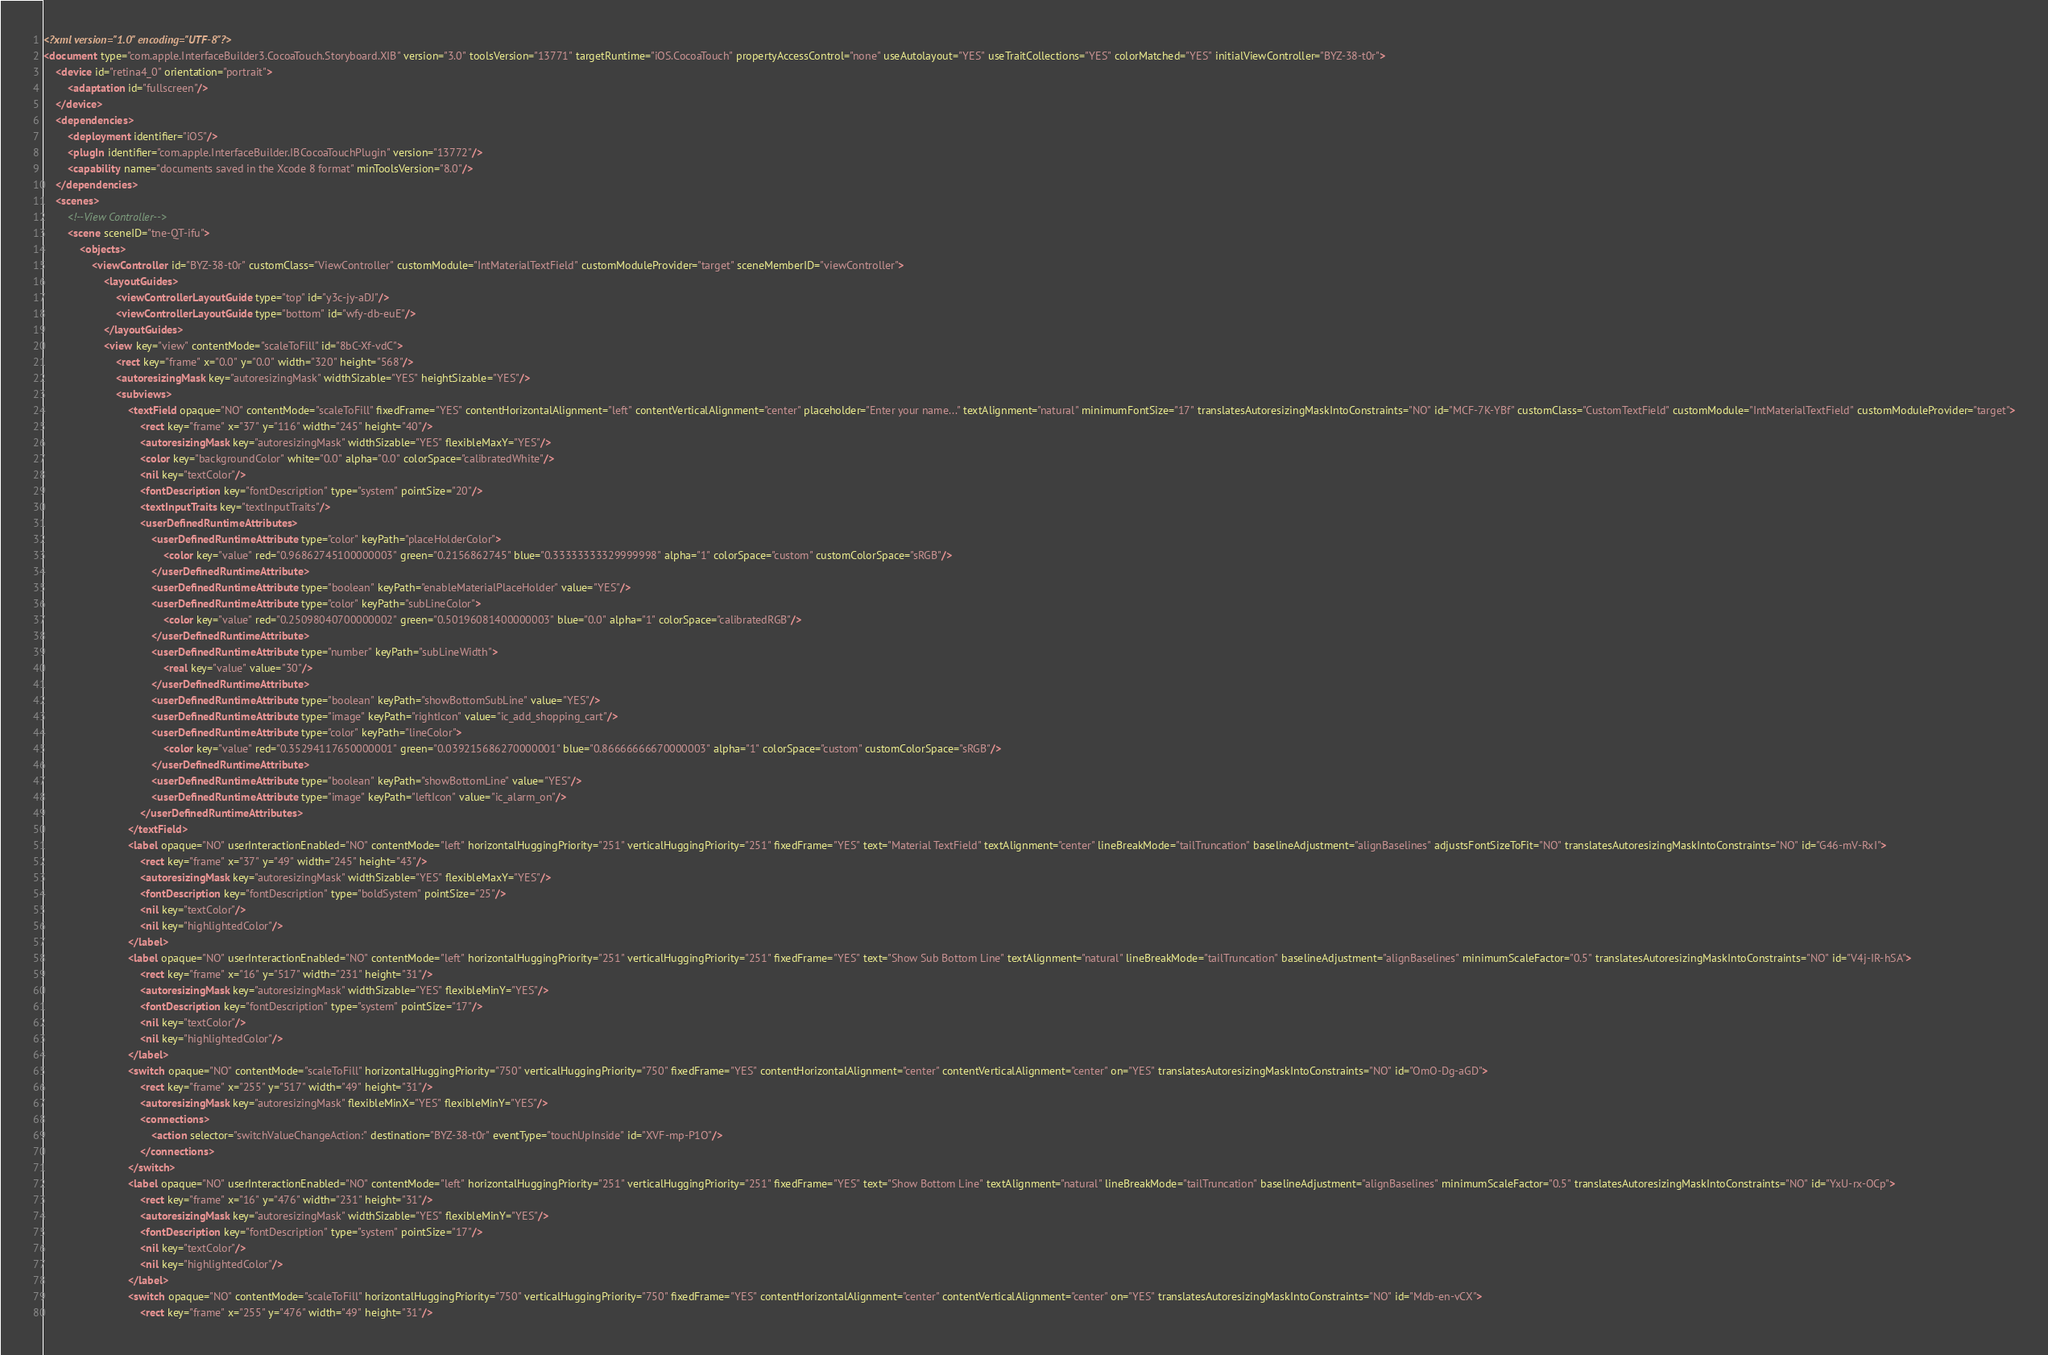<code> <loc_0><loc_0><loc_500><loc_500><_XML_><?xml version="1.0" encoding="UTF-8"?>
<document type="com.apple.InterfaceBuilder3.CocoaTouch.Storyboard.XIB" version="3.0" toolsVersion="13771" targetRuntime="iOS.CocoaTouch" propertyAccessControl="none" useAutolayout="YES" useTraitCollections="YES" colorMatched="YES" initialViewController="BYZ-38-t0r">
    <device id="retina4_0" orientation="portrait">
        <adaptation id="fullscreen"/>
    </device>
    <dependencies>
        <deployment identifier="iOS"/>
        <plugIn identifier="com.apple.InterfaceBuilder.IBCocoaTouchPlugin" version="13772"/>
        <capability name="documents saved in the Xcode 8 format" minToolsVersion="8.0"/>
    </dependencies>
    <scenes>
        <!--View Controller-->
        <scene sceneID="tne-QT-ifu">
            <objects>
                <viewController id="BYZ-38-t0r" customClass="ViewController" customModule="IntMaterialTextField" customModuleProvider="target" sceneMemberID="viewController">
                    <layoutGuides>
                        <viewControllerLayoutGuide type="top" id="y3c-jy-aDJ"/>
                        <viewControllerLayoutGuide type="bottom" id="wfy-db-euE"/>
                    </layoutGuides>
                    <view key="view" contentMode="scaleToFill" id="8bC-Xf-vdC">
                        <rect key="frame" x="0.0" y="0.0" width="320" height="568"/>
                        <autoresizingMask key="autoresizingMask" widthSizable="YES" heightSizable="YES"/>
                        <subviews>
                            <textField opaque="NO" contentMode="scaleToFill" fixedFrame="YES" contentHorizontalAlignment="left" contentVerticalAlignment="center" placeholder="Enter your name..." textAlignment="natural" minimumFontSize="17" translatesAutoresizingMaskIntoConstraints="NO" id="MCF-7K-YBf" customClass="CustomTextField" customModule="IntMaterialTextField" customModuleProvider="target">
                                <rect key="frame" x="37" y="116" width="245" height="40"/>
                                <autoresizingMask key="autoresizingMask" widthSizable="YES" flexibleMaxY="YES"/>
                                <color key="backgroundColor" white="0.0" alpha="0.0" colorSpace="calibratedWhite"/>
                                <nil key="textColor"/>
                                <fontDescription key="fontDescription" type="system" pointSize="20"/>
                                <textInputTraits key="textInputTraits"/>
                                <userDefinedRuntimeAttributes>
                                    <userDefinedRuntimeAttribute type="color" keyPath="placeHolderColor">
                                        <color key="value" red="0.96862745100000003" green="0.2156862745" blue="0.33333333329999998" alpha="1" colorSpace="custom" customColorSpace="sRGB"/>
                                    </userDefinedRuntimeAttribute>
                                    <userDefinedRuntimeAttribute type="boolean" keyPath="enableMaterialPlaceHolder" value="YES"/>
                                    <userDefinedRuntimeAttribute type="color" keyPath="subLineColor">
                                        <color key="value" red="0.25098040700000002" green="0.50196081400000003" blue="0.0" alpha="1" colorSpace="calibratedRGB"/>
                                    </userDefinedRuntimeAttribute>
                                    <userDefinedRuntimeAttribute type="number" keyPath="subLineWidth">
                                        <real key="value" value="30"/>
                                    </userDefinedRuntimeAttribute>
                                    <userDefinedRuntimeAttribute type="boolean" keyPath="showBottomSubLine" value="YES"/>
                                    <userDefinedRuntimeAttribute type="image" keyPath="rightIcon" value="ic_add_shopping_cart"/>
                                    <userDefinedRuntimeAttribute type="color" keyPath="lineColor">
                                        <color key="value" red="0.35294117650000001" green="0.039215686270000001" blue="0.86666666670000003" alpha="1" colorSpace="custom" customColorSpace="sRGB"/>
                                    </userDefinedRuntimeAttribute>
                                    <userDefinedRuntimeAttribute type="boolean" keyPath="showBottomLine" value="YES"/>
                                    <userDefinedRuntimeAttribute type="image" keyPath="leftIcon" value="ic_alarm_on"/>
                                </userDefinedRuntimeAttributes>
                            </textField>
                            <label opaque="NO" userInteractionEnabled="NO" contentMode="left" horizontalHuggingPriority="251" verticalHuggingPriority="251" fixedFrame="YES" text="Material TextField" textAlignment="center" lineBreakMode="tailTruncation" baselineAdjustment="alignBaselines" adjustsFontSizeToFit="NO" translatesAutoresizingMaskIntoConstraints="NO" id="G46-mV-RxI">
                                <rect key="frame" x="37" y="49" width="245" height="43"/>
                                <autoresizingMask key="autoresizingMask" widthSizable="YES" flexibleMaxY="YES"/>
                                <fontDescription key="fontDescription" type="boldSystem" pointSize="25"/>
                                <nil key="textColor"/>
                                <nil key="highlightedColor"/>
                            </label>
                            <label opaque="NO" userInteractionEnabled="NO" contentMode="left" horizontalHuggingPriority="251" verticalHuggingPriority="251" fixedFrame="YES" text="Show Sub Bottom Line" textAlignment="natural" lineBreakMode="tailTruncation" baselineAdjustment="alignBaselines" minimumScaleFactor="0.5" translatesAutoresizingMaskIntoConstraints="NO" id="V4j-IR-hSA">
                                <rect key="frame" x="16" y="517" width="231" height="31"/>
                                <autoresizingMask key="autoresizingMask" widthSizable="YES" flexibleMinY="YES"/>
                                <fontDescription key="fontDescription" type="system" pointSize="17"/>
                                <nil key="textColor"/>
                                <nil key="highlightedColor"/>
                            </label>
                            <switch opaque="NO" contentMode="scaleToFill" horizontalHuggingPriority="750" verticalHuggingPriority="750" fixedFrame="YES" contentHorizontalAlignment="center" contentVerticalAlignment="center" on="YES" translatesAutoresizingMaskIntoConstraints="NO" id="OmO-Dg-aGD">
                                <rect key="frame" x="255" y="517" width="49" height="31"/>
                                <autoresizingMask key="autoresizingMask" flexibleMinX="YES" flexibleMinY="YES"/>
                                <connections>
                                    <action selector="switchValueChangeAction:" destination="BYZ-38-t0r" eventType="touchUpInside" id="XVF-mp-P1O"/>
                                </connections>
                            </switch>
                            <label opaque="NO" userInteractionEnabled="NO" contentMode="left" horizontalHuggingPriority="251" verticalHuggingPriority="251" fixedFrame="YES" text="Show Bottom Line" textAlignment="natural" lineBreakMode="tailTruncation" baselineAdjustment="alignBaselines" minimumScaleFactor="0.5" translatesAutoresizingMaskIntoConstraints="NO" id="YxU-rx-OCp">
                                <rect key="frame" x="16" y="476" width="231" height="31"/>
                                <autoresizingMask key="autoresizingMask" widthSizable="YES" flexibleMinY="YES"/>
                                <fontDescription key="fontDescription" type="system" pointSize="17"/>
                                <nil key="textColor"/>
                                <nil key="highlightedColor"/>
                            </label>
                            <switch opaque="NO" contentMode="scaleToFill" horizontalHuggingPriority="750" verticalHuggingPriority="750" fixedFrame="YES" contentHorizontalAlignment="center" contentVerticalAlignment="center" on="YES" translatesAutoresizingMaskIntoConstraints="NO" id="Mdb-en-vCX">
                                <rect key="frame" x="255" y="476" width="49" height="31"/></code> 